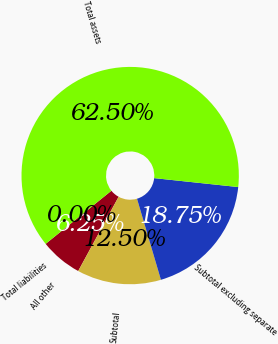Convert chart to OTSL. <chart><loc_0><loc_0><loc_500><loc_500><pie_chart><fcel>All other<fcel>Subtotal<fcel>Subtotal excluding separate<fcel>Total assets<fcel>Total liabilities<nl><fcel>6.25%<fcel>12.5%<fcel>18.75%<fcel>62.5%<fcel>0.0%<nl></chart> 